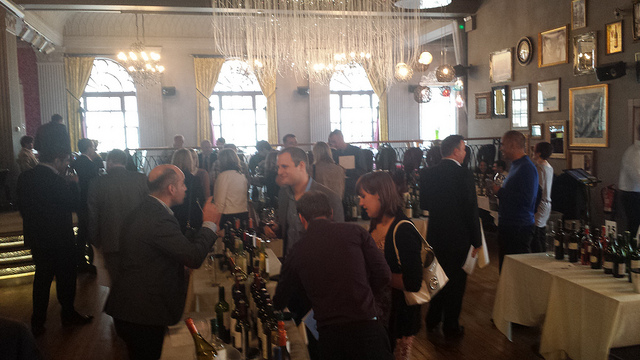<image>What type of animals are gathering together? There are no animals gathering together in the image. It appears to be humans. What type of animals are gathering together? I don't know what type of animals are gathering together. There seems to be no animals in the image. 